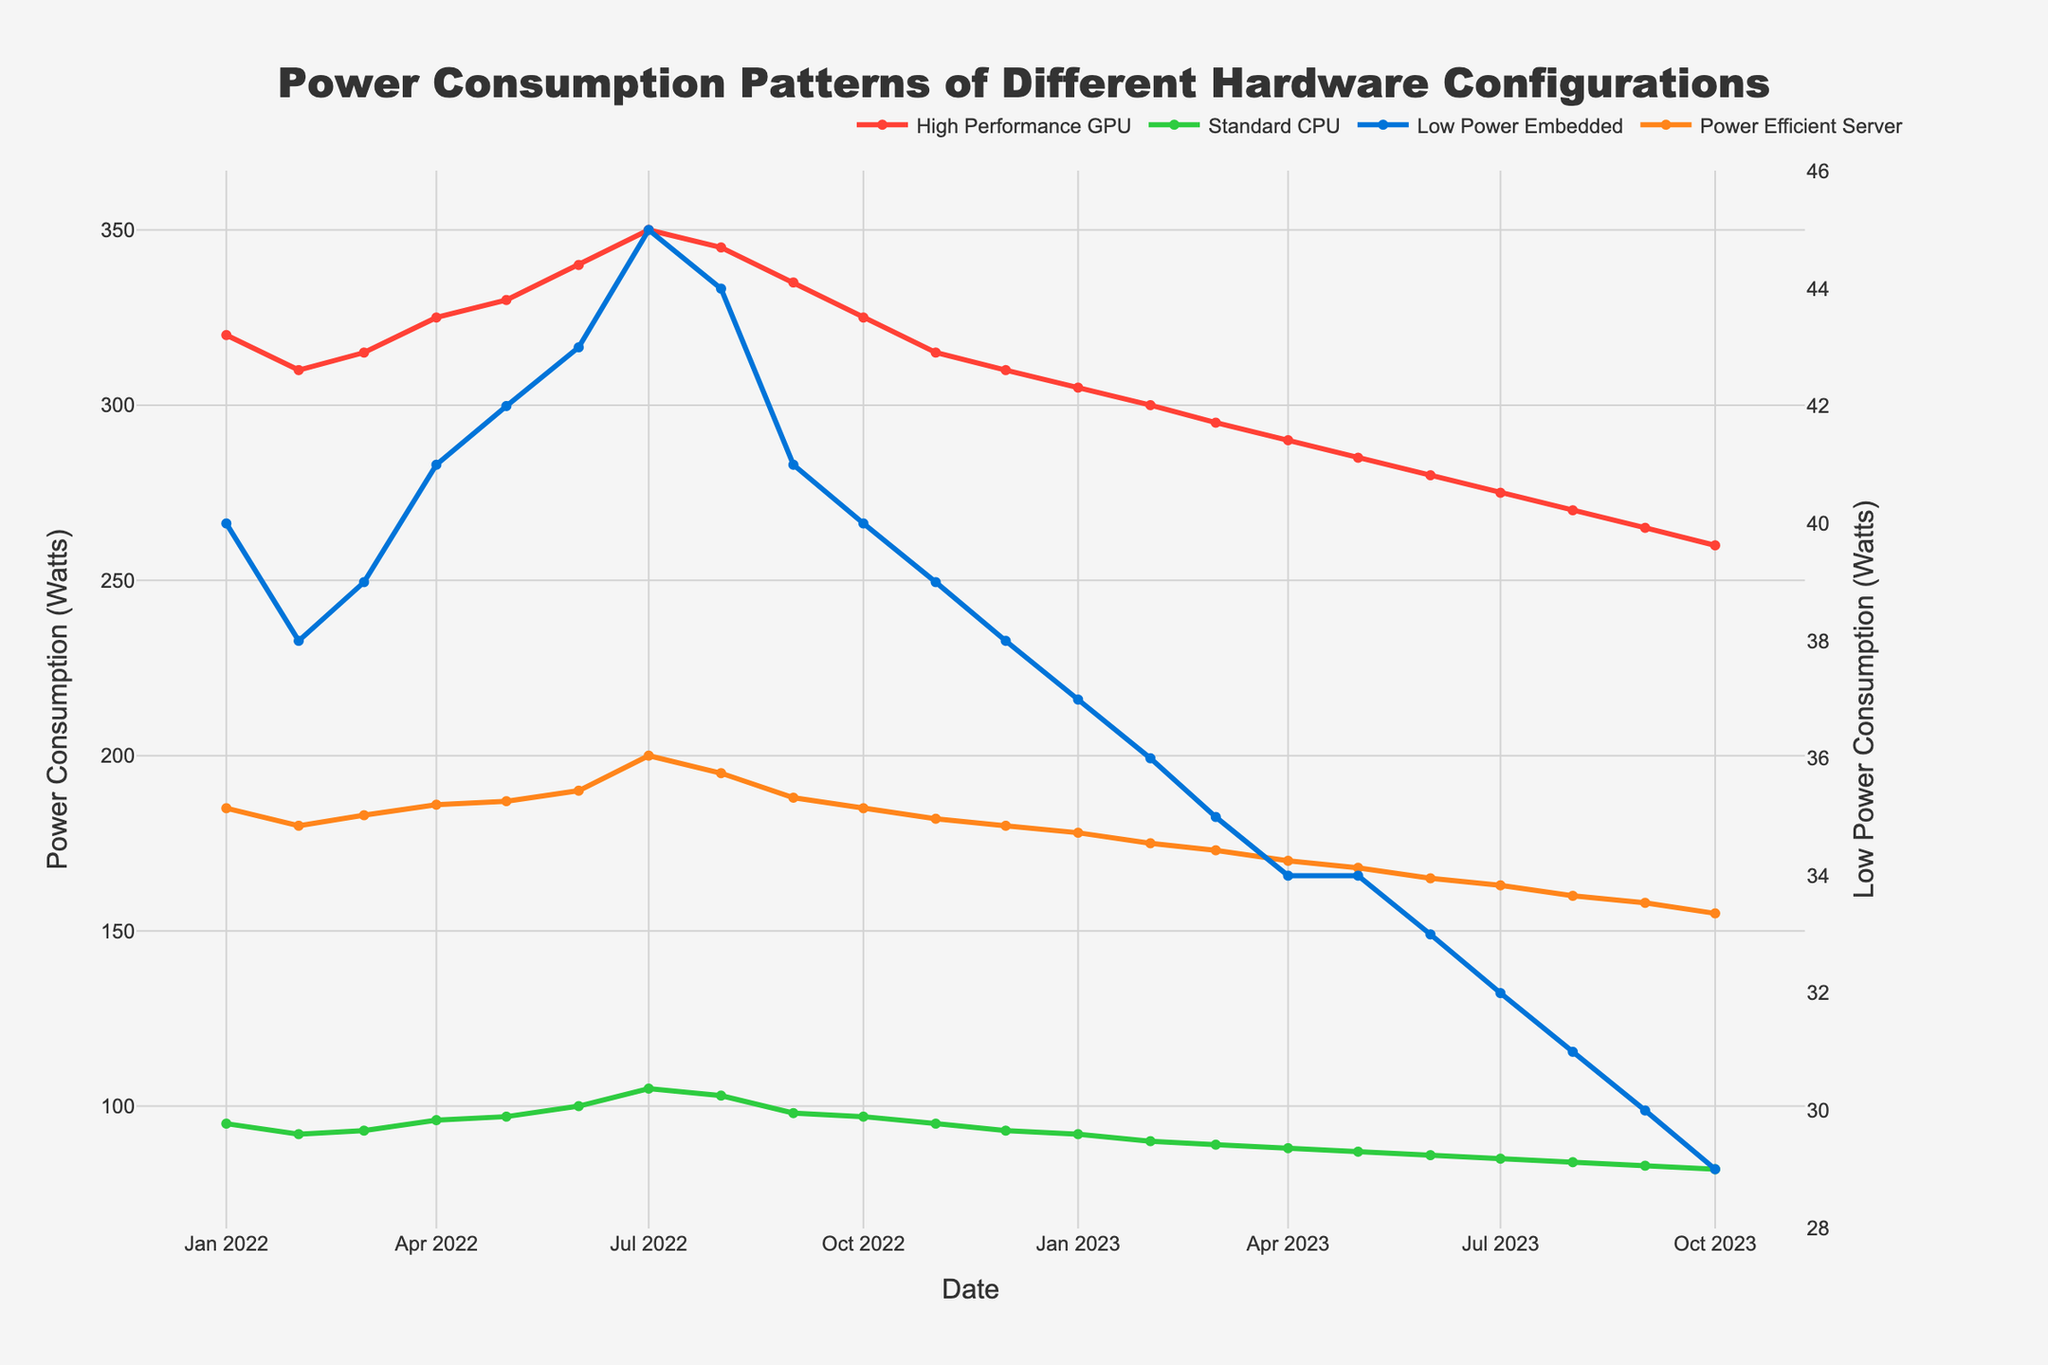What's the title of the figure? The title is usually at the top of the plot; in this case, it states "Power Consumption Patterns of Different Hardware Configurations".
Answer: Power Consumption Patterns of Different Hardware Configurations What date does the High Performance GPU configuration reach its peak power consumption? By examining the trace for the High Performance GPU, the highest value, which is approximately 350 Watts, appears around July 2022.
Answer: July 2022 Which configuration generally consumes the least power? By comparing the y-axis values for all configurations, it's observed that the Low Power Embedded configuration consistently has the lowest values.
Answer: Low Power Embedded Configuration How does the power consumption of Standard CPU Config compare to Power Efficient Server Config in January 2023? Check the data points for January 2023. Standard CPU Config consumes 92 Watts, while Power Efficient Server Config consumes 178 Watts.
Answer: Standard CPU Config is lower What is the general trend of the High Performance GPU config's power consumption over the year? Observing the plot, the power consumption of the High Performance GPU config shows an overall decreasing trend after peaking in July 2022.
Answer: Decreasing trend Between which months does the Power Efficient Server Config show a significant drop in power consumption? The plot indicates a noticeable decline in Power Efficient Server Config's power consumption between December 2022 and January 2023.
Answer: December 2022 and January 2023 What is the difference in power consumption between the highest and lowest recorded values for the Low Power Embedded config? The highest value is 45 Watts (July 2022) and the lowest is 29 Watts (October 2023). The difference is 45 - 29 = 16 Watts.
Answer: 16 Watts Which month shows the highest power consumption for the Standard CPU config, and what is its value? Check the highest peak in the Standard CPU trace, which seems to be around July 2022, with a value of approximately 105 Watts.
Answer: July 2022, 105 Watts What pattern can be observed in the power consumption of all configurations between June and September 2022? During this period, all configurations show a peak in June/July followed by a gradual decrease towards September.
Answer: Peak in June/July, decrease towards September 